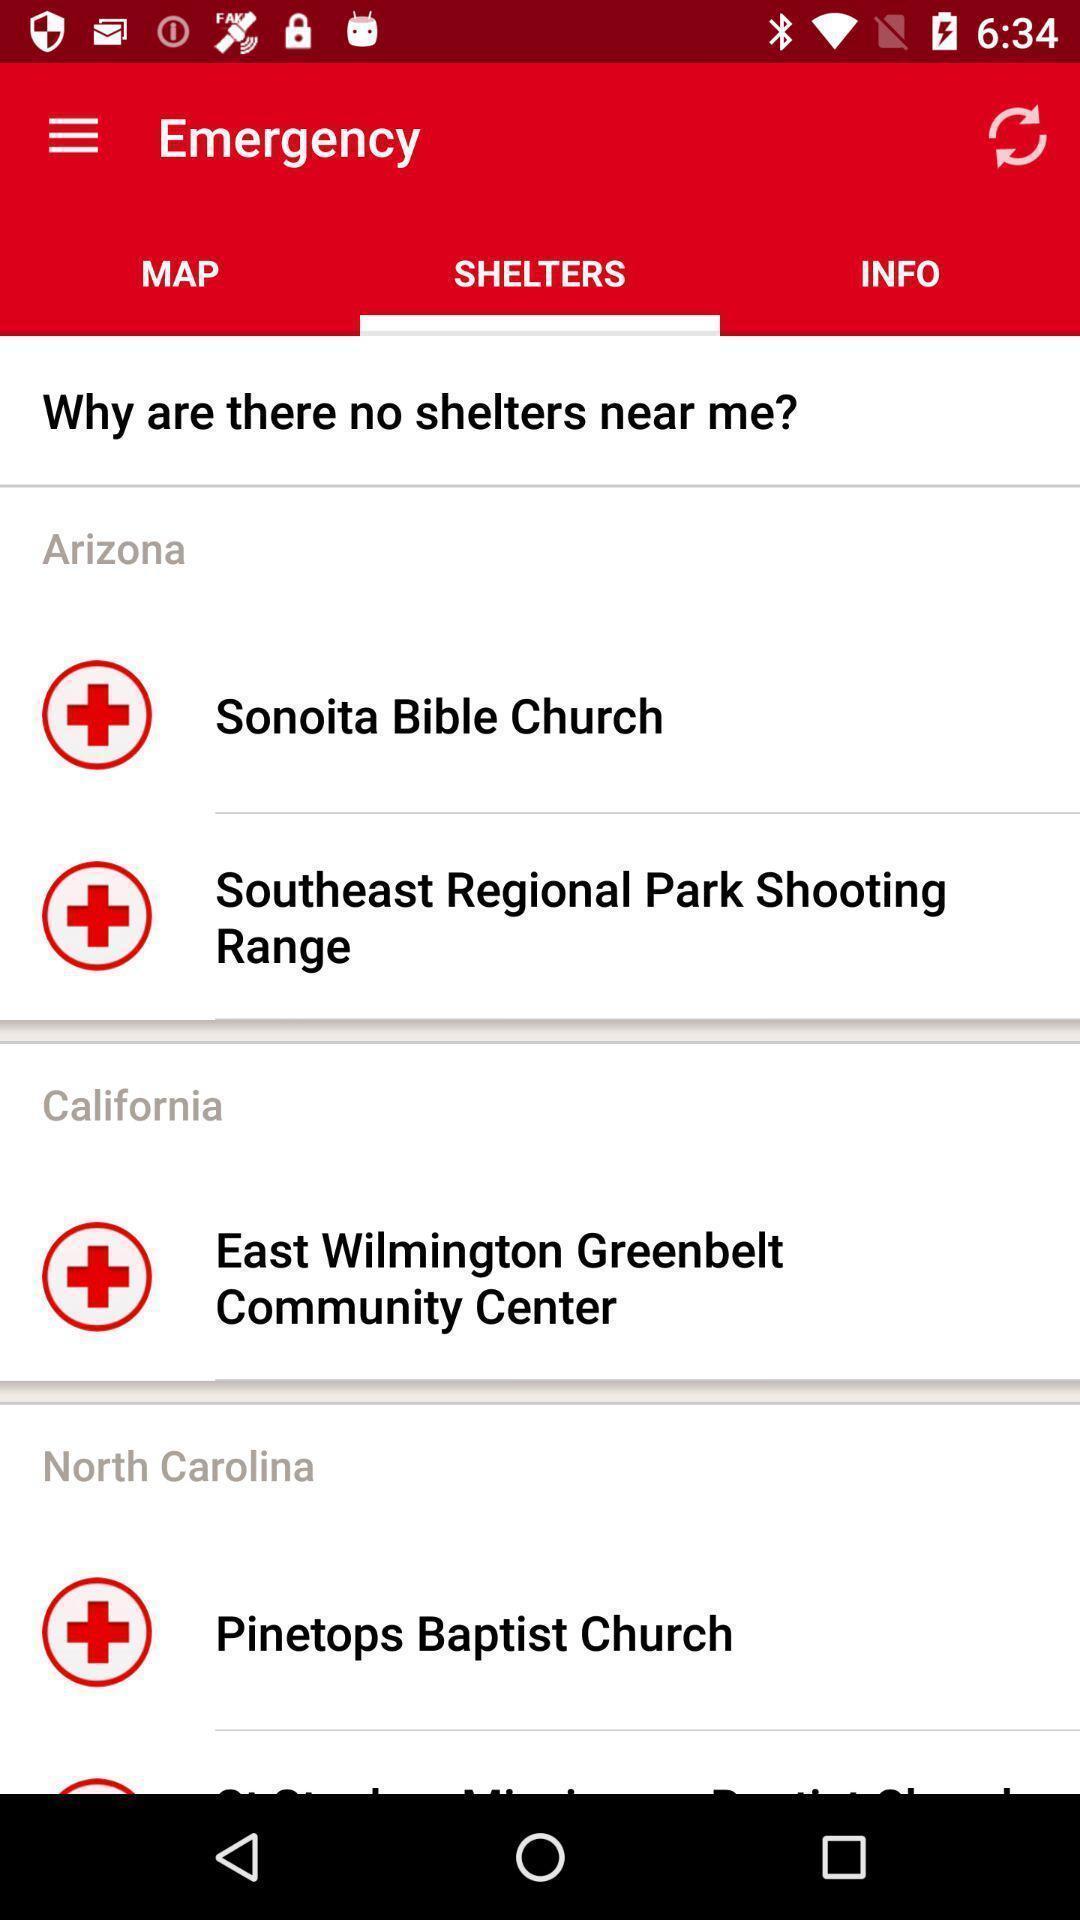What is the overall content of this screenshot? Screen shows no shelters nearby. 